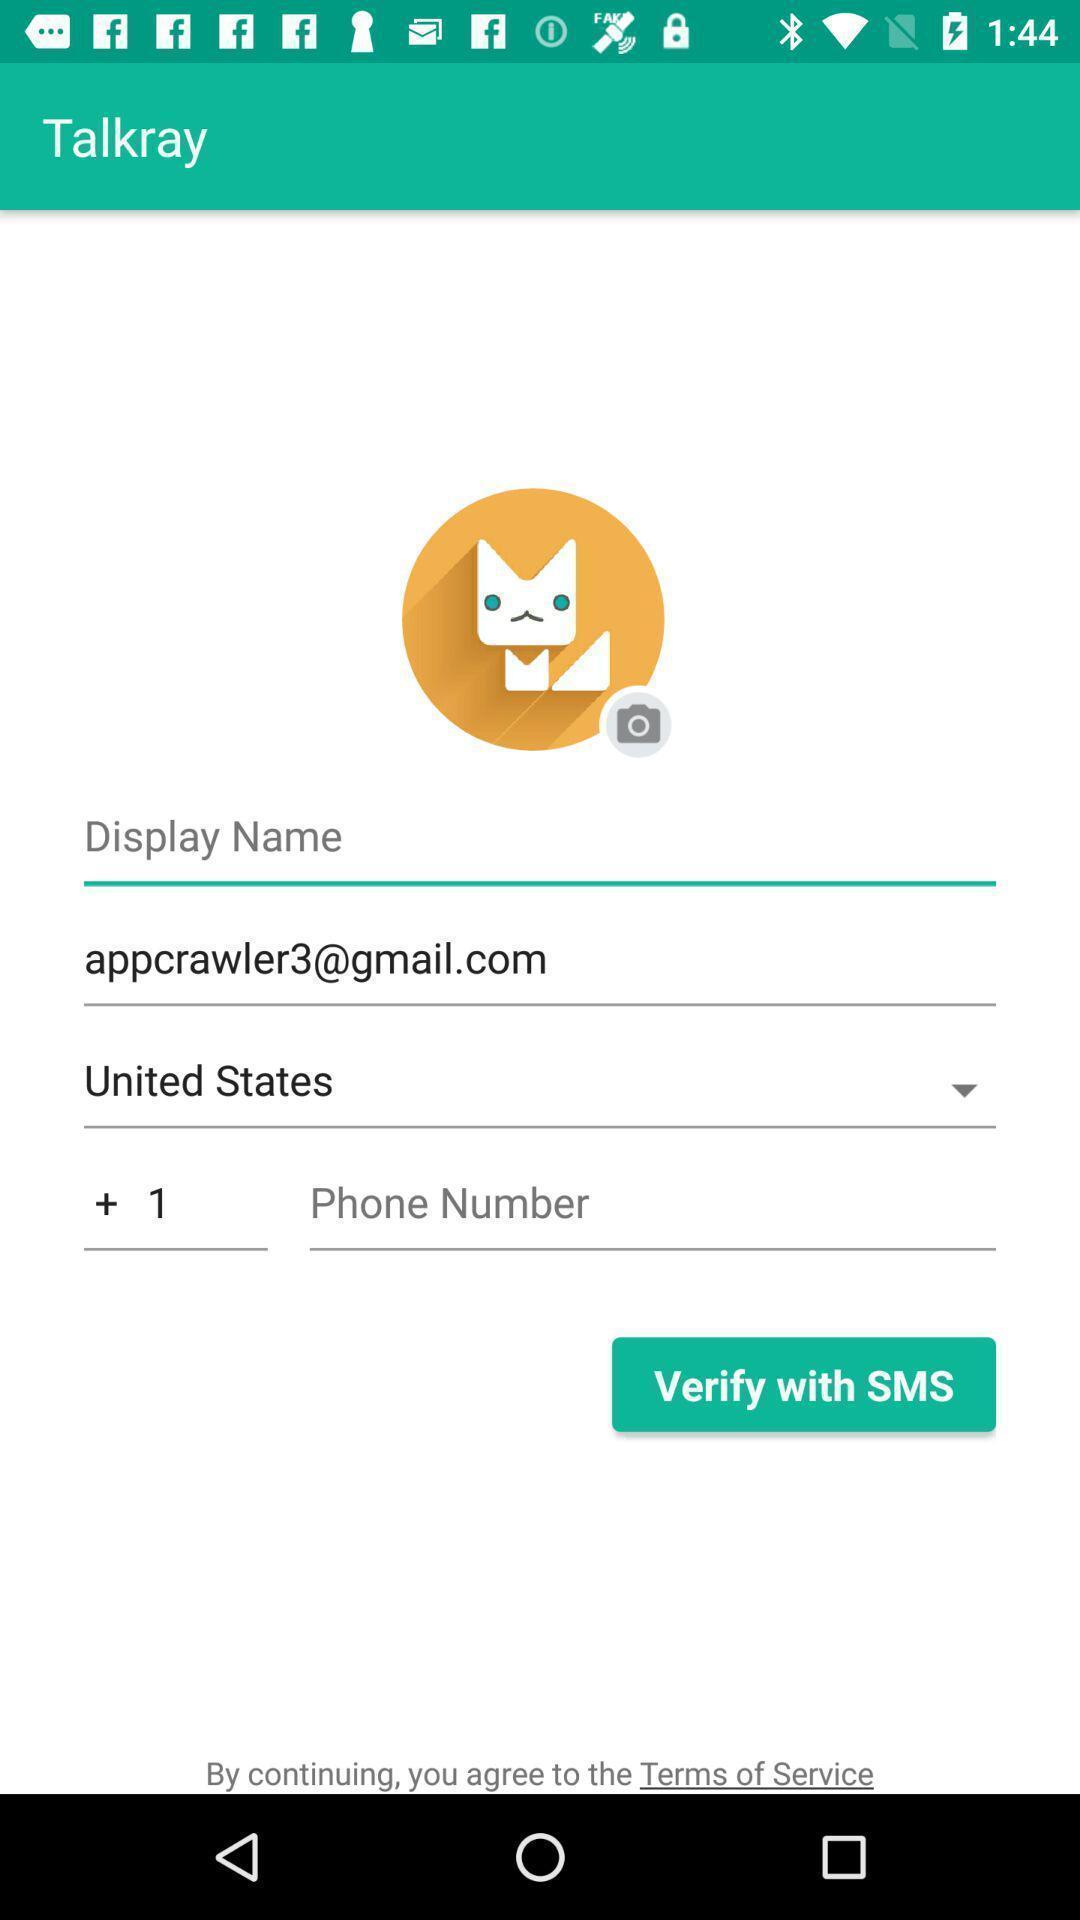What can you discern from this picture? Verification page for the social app. 